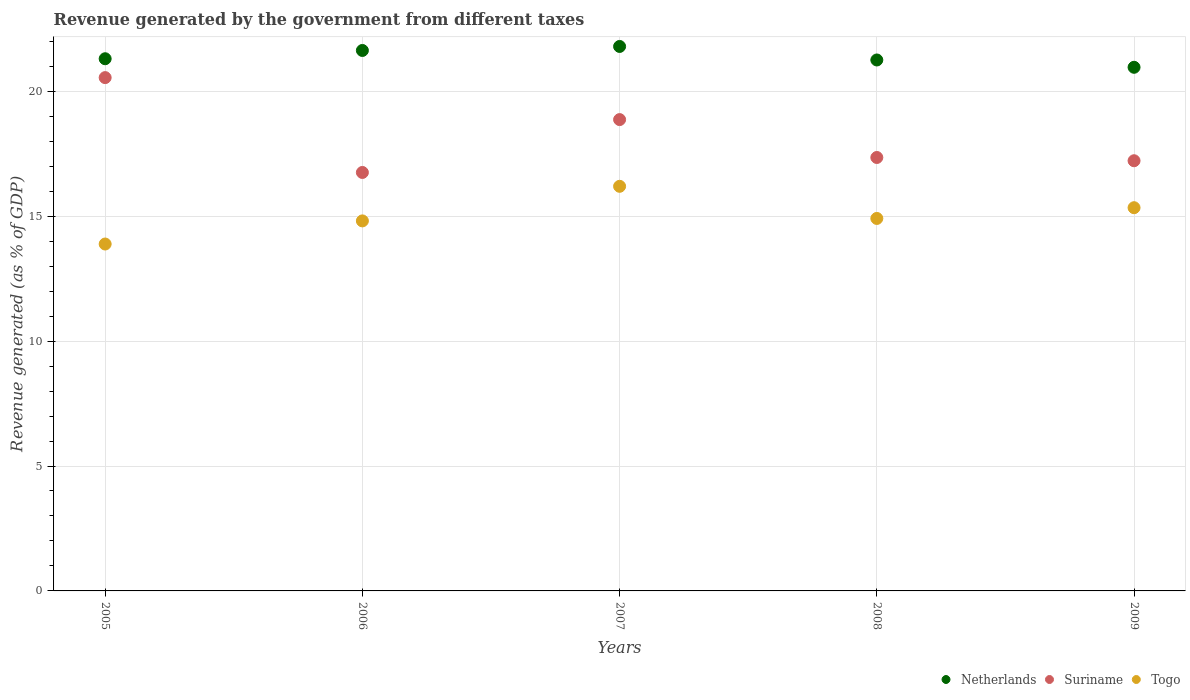How many different coloured dotlines are there?
Your response must be concise. 3. What is the revenue generated by the government in Netherlands in 2006?
Offer a terse response. 21.63. Across all years, what is the maximum revenue generated by the government in Togo?
Provide a short and direct response. 16.2. Across all years, what is the minimum revenue generated by the government in Suriname?
Offer a terse response. 16.75. In which year was the revenue generated by the government in Suriname maximum?
Provide a short and direct response. 2005. What is the total revenue generated by the government in Togo in the graph?
Your answer should be very brief. 75.14. What is the difference between the revenue generated by the government in Netherlands in 2007 and that in 2008?
Your response must be concise. 0.54. What is the difference between the revenue generated by the government in Togo in 2005 and the revenue generated by the government in Suriname in 2009?
Keep it short and to the point. -3.33. What is the average revenue generated by the government in Togo per year?
Offer a very short reply. 15.03. In the year 2006, what is the difference between the revenue generated by the government in Suriname and revenue generated by the government in Togo?
Provide a succinct answer. 1.94. In how many years, is the revenue generated by the government in Netherlands greater than 11 %?
Provide a short and direct response. 5. What is the ratio of the revenue generated by the government in Netherlands in 2005 to that in 2006?
Provide a short and direct response. 0.98. What is the difference between the highest and the second highest revenue generated by the government in Togo?
Your answer should be compact. 0.86. What is the difference between the highest and the lowest revenue generated by the government in Netherlands?
Ensure brevity in your answer.  0.83. Is it the case that in every year, the sum of the revenue generated by the government in Netherlands and revenue generated by the government in Suriname  is greater than the revenue generated by the government in Togo?
Make the answer very short. Yes. Does the revenue generated by the government in Netherlands monotonically increase over the years?
Your response must be concise. No. Is the revenue generated by the government in Netherlands strictly less than the revenue generated by the government in Togo over the years?
Provide a succinct answer. No. How many years are there in the graph?
Give a very brief answer. 5. Are the values on the major ticks of Y-axis written in scientific E-notation?
Your response must be concise. No. Does the graph contain any zero values?
Your answer should be compact. No. Where does the legend appear in the graph?
Make the answer very short. Bottom right. What is the title of the graph?
Provide a short and direct response. Revenue generated by the government from different taxes. Does "Haiti" appear as one of the legend labels in the graph?
Keep it short and to the point. No. What is the label or title of the Y-axis?
Keep it short and to the point. Revenue generated (as % of GDP). What is the Revenue generated (as % of GDP) in Netherlands in 2005?
Your response must be concise. 21.3. What is the Revenue generated (as % of GDP) of Suriname in 2005?
Provide a succinct answer. 20.55. What is the Revenue generated (as % of GDP) of Togo in 2005?
Your answer should be compact. 13.88. What is the Revenue generated (as % of GDP) of Netherlands in 2006?
Your response must be concise. 21.63. What is the Revenue generated (as % of GDP) of Suriname in 2006?
Your answer should be very brief. 16.75. What is the Revenue generated (as % of GDP) in Togo in 2006?
Offer a terse response. 14.81. What is the Revenue generated (as % of GDP) in Netherlands in 2007?
Offer a terse response. 21.79. What is the Revenue generated (as % of GDP) of Suriname in 2007?
Provide a short and direct response. 18.87. What is the Revenue generated (as % of GDP) of Togo in 2007?
Provide a succinct answer. 16.2. What is the Revenue generated (as % of GDP) in Netherlands in 2008?
Give a very brief answer. 21.25. What is the Revenue generated (as % of GDP) in Suriname in 2008?
Offer a terse response. 17.35. What is the Revenue generated (as % of GDP) of Togo in 2008?
Give a very brief answer. 14.91. What is the Revenue generated (as % of GDP) in Netherlands in 2009?
Provide a succinct answer. 20.96. What is the Revenue generated (as % of GDP) in Suriname in 2009?
Offer a terse response. 17.22. What is the Revenue generated (as % of GDP) in Togo in 2009?
Offer a terse response. 15.34. Across all years, what is the maximum Revenue generated (as % of GDP) of Netherlands?
Give a very brief answer. 21.79. Across all years, what is the maximum Revenue generated (as % of GDP) of Suriname?
Provide a short and direct response. 20.55. Across all years, what is the maximum Revenue generated (as % of GDP) of Togo?
Your answer should be very brief. 16.2. Across all years, what is the minimum Revenue generated (as % of GDP) of Netherlands?
Offer a terse response. 20.96. Across all years, what is the minimum Revenue generated (as % of GDP) of Suriname?
Offer a terse response. 16.75. Across all years, what is the minimum Revenue generated (as % of GDP) in Togo?
Give a very brief answer. 13.88. What is the total Revenue generated (as % of GDP) in Netherlands in the graph?
Offer a very short reply. 106.94. What is the total Revenue generated (as % of GDP) of Suriname in the graph?
Ensure brevity in your answer.  90.73. What is the total Revenue generated (as % of GDP) in Togo in the graph?
Your answer should be compact. 75.14. What is the difference between the Revenue generated (as % of GDP) in Netherlands in 2005 and that in 2006?
Make the answer very short. -0.33. What is the difference between the Revenue generated (as % of GDP) in Suriname in 2005 and that in 2006?
Give a very brief answer. 3.8. What is the difference between the Revenue generated (as % of GDP) of Togo in 2005 and that in 2006?
Your response must be concise. -0.93. What is the difference between the Revenue generated (as % of GDP) of Netherlands in 2005 and that in 2007?
Give a very brief answer. -0.49. What is the difference between the Revenue generated (as % of GDP) of Suriname in 2005 and that in 2007?
Keep it short and to the point. 1.68. What is the difference between the Revenue generated (as % of GDP) in Togo in 2005 and that in 2007?
Your response must be concise. -2.31. What is the difference between the Revenue generated (as % of GDP) of Netherlands in 2005 and that in 2008?
Make the answer very short. 0.05. What is the difference between the Revenue generated (as % of GDP) in Suriname in 2005 and that in 2008?
Keep it short and to the point. 3.2. What is the difference between the Revenue generated (as % of GDP) in Togo in 2005 and that in 2008?
Your response must be concise. -1.02. What is the difference between the Revenue generated (as % of GDP) of Netherlands in 2005 and that in 2009?
Ensure brevity in your answer.  0.34. What is the difference between the Revenue generated (as % of GDP) in Suriname in 2005 and that in 2009?
Offer a very short reply. 3.33. What is the difference between the Revenue generated (as % of GDP) in Togo in 2005 and that in 2009?
Offer a terse response. -1.45. What is the difference between the Revenue generated (as % of GDP) of Netherlands in 2006 and that in 2007?
Ensure brevity in your answer.  -0.16. What is the difference between the Revenue generated (as % of GDP) of Suriname in 2006 and that in 2007?
Your response must be concise. -2.12. What is the difference between the Revenue generated (as % of GDP) in Togo in 2006 and that in 2007?
Ensure brevity in your answer.  -1.38. What is the difference between the Revenue generated (as % of GDP) in Netherlands in 2006 and that in 2008?
Provide a succinct answer. 0.38. What is the difference between the Revenue generated (as % of GDP) of Suriname in 2006 and that in 2008?
Offer a very short reply. -0.6. What is the difference between the Revenue generated (as % of GDP) of Togo in 2006 and that in 2008?
Your response must be concise. -0.1. What is the difference between the Revenue generated (as % of GDP) of Netherlands in 2006 and that in 2009?
Your answer should be compact. 0.67. What is the difference between the Revenue generated (as % of GDP) of Suriname in 2006 and that in 2009?
Provide a succinct answer. -0.47. What is the difference between the Revenue generated (as % of GDP) in Togo in 2006 and that in 2009?
Provide a short and direct response. -0.53. What is the difference between the Revenue generated (as % of GDP) of Netherlands in 2007 and that in 2008?
Your answer should be very brief. 0.54. What is the difference between the Revenue generated (as % of GDP) in Suriname in 2007 and that in 2008?
Provide a succinct answer. 1.52. What is the difference between the Revenue generated (as % of GDP) of Togo in 2007 and that in 2008?
Your answer should be very brief. 1.29. What is the difference between the Revenue generated (as % of GDP) of Netherlands in 2007 and that in 2009?
Provide a short and direct response. 0.83. What is the difference between the Revenue generated (as % of GDP) in Suriname in 2007 and that in 2009?
Keep it short and to the point. 1.65. What is the difference between the Revenue generated (as % of GDP) in Togo in 2007 and that in 2009?
Offer a terse response. 0.86. What is the difference between the Revenue generated (as % of GDP) of Netherlands in 2008 and that in 2009?
Keep it short and to the point. 0.29. What is the difference between the Revenue generated (as % of GDP) of Suriname in 2008 and that in 2009?
Ensure brevity in your answer.  0.13. What is the difference between the Revenue generated (as % of GDP) in Togo in 2008 and that in 2009?
Your answer should be compact. -0.43. What is the difference between the Revenue generated (as % of GDP) of Netherlands in 2005 and the Revenue generated (as % of GDP) of Suriname in 2006?
Your answer should be compact. 4.55. What is the difference between the Revenue generated (as % of GDP) of Netherlands in 2005 and the Revenue generated (as % of GDP) of Togo in 2006?
Ensure brevity in your answer.  6.49. What is the difference between the Revenue generated (as % of GDP) in Suriname in 2005 and the Revenue generated (as % of GDP) in Togo in 2006?
Your answer should be very brief. 5.74. What is the difference between the Revenue generated (as % of GDP) in Netherlands in 2005 and the Revenue generated (as % of GDP) in Suriname in 2007?
Provide a short and direct response. 2.44. What is the difference between the Revenue generated (as % of GDP) in Netherlands in 2005 and the Revenue generated (as % of GDP) in Togo in 2007?
Ensure brevity in your answer.  5.11. What is the difference between the Revenue generated (as % of GDP) of Suriname in 2005 and the Revenue generated (as % of GDP) of Togo in 2007?
Give a very brief answer. 4.35. What is the difference between the Revenue generated (as % of GDP) of Netherlands in 2005 and the Revenue generated (as % of GDP) of Suriname in 2008?
Ensure brevity in your answer.  3.95. What is the difference between the Revenue generated (as % of GDP) in Netherlands in 2005 and the Revenue generated (as % of GDP) in Togo in 2008?
Offer a terse response. 6.39. What is the difference between the Revenue generated (as % of GDP) of Suriname in 2005 and the Revenue generated (as % of GDP) of Togo in 2008?
Keep it short and to the point. 5.64. What is the difference between the Revenue generated (as % of GDP) in Netherlands in 2005 and the Revenue generated (as % of GDP) in Suriname in 2009?
Your answer should be very brief. 4.08. What is the difference between the Revenue generated (as % of GDP) in Netherlands in 2005 and the Revenue generated (as % of GDP) in Togo in 2009?
Your answer should be very brief. 5.96. What is the difference between the Revenue generated (as % of GDP) of Suriname in 2005 and the Revenue generated (as % of GDP) of Togo in 2009?
Give a very brief answer. 5.21. What is the difference between the Revenue generated (as % of GDP) of Netherlands in 2006 and the Revenue generated (as % of GDP) of Suriname in 2007?
Ensure brevity in your answer.  2.77. What is the difference between the Revenue generated (as % of GDP) in Netherlands in 2006 and the Revenue generated (as % of GDP) in Togo in 2007?
Give a very brief answer. 5.44. What is the difference between the Revenue generated (as % of GDP) in Suriname in 2006 and the Revenue generated (as % of GDP) in Togo in 2007?
Your answer should be compact. 0.55. What is the difference between the Revenue generated (as % of GDP) of Netherlands in 2006 and the Revenue generated (as % of GDP) of Suriname in 2008?
Make the answer very short. 4.28. What is the difference between the Revenue generated (as % of GDP) of Netherlands in 2006 and the Revenue generated (as % of GDP) of Togo in 2008?
Your answer should be very brief. 6.72. What is the difference between the Revenue generated (as % of GDP) in Suriname in 2006 and the Revenue generated (as % of GDP) in Togo in 2008?
Ensure brevity in your answer.  1.84. What is the difference between the Revenue generated (as % of GDP) in Netherlands in 2006 and the Revenue generated (as % of GDP) in Suriname in 2009?
Your answer should be compact. 4.41. What is the difference between the Revenue generated (as % of GDP) in Netherlands in 2006 and the Revenue generated (as % of GDP) in Togo in 2009?
Make the answer very short. 6.29. What is the difference between the Revenue generated (as % of GDP) in Suriname in 2006 and the Revenue generated (as % of GDP) in Togo in 2009?
Your response must be concise. 1.41. What is the difference between the Revenue generated (as % of GDP) of Netherlands in 2007 and the Revenue generated (as % of GDP) of Suriname in 2008?
Make the answer very short. 4.44. What is the difference between the Revenue generated (as % of GDP) of Netherlands in 2007 and the Revenue generated (as % of GDP) of Togo in 2008?
Make the answer very short. 6.88. What is the difference between the Revenue generated (as % of GDP) in Suriname in 2007 and the Revenue generated (as % of GDP) in Togo in 2008?
Your response must be concise. 3.96. What is the difference between the Revenue generated (as % of GDP) in Netherlands in 2007 and the Revenue generated (as % of GDP) in Suriname in 2009?
Make the answer very short. 4.57. What is the difference between the Revenue generated (as % of GDP) of Netherlands in 2007 and the Revenue generated (as % of GDP) of Togo in 2009?
Make the answer very short. 6.45. What is the difference between the Revenue generated (as % of GDP) in Suriname in 2007 and the Revenue generated (as % of GDP) in Togo in 2009?
Offer a terse response. 3.53. What is the difference between the Revenue generated (as % of GDP) in Netherlands in 2008 and the Revenue generated (as % of GDP) in Suriname in 2009?
Make the answer very short. 4.03. What is the difference between the Revenue generated (as % of GDP) of Netherlands in 2008 and the Revenue generated (as % of GDP) of Togo in 2009?
Provide a succinct answer. 5.91. What is the difference between the Revenue generated (as % of GDP) in Suriname in 2008 and the Revenue generated (as % of GDP) in Togo in 2009?
Provide a short and direct response. 2.01. What is the average Revenue generated (as % of GDP) in Netherlands per year?
Keep it short and to the point. 21.39. What is the average Revenue generated (as % of GDP) of Suriname per year?
Your answer should be very brief. 18.15. What is the average Revenue generated (as % of GDP) of Togo per year?
Provide a succinct answer. 15.03. In the year 2005, what is the difference between the Revenue generated (as % of GDP) in Netherlands and Revenue generated (as % of GDP) in Suriname?
Provide a short and direct response. 0.76. In the year 2005, what is the difference between the Revenue generated (as % of GDP) in Netherlands and Revenue generated (as % of GDP) in Togo?
Ensure brevity in your answer.  7.42. In the year 2005, what is the difference between the Revenue generated (as % of GDP) in Suriname and Revenue generated (as % of GDP) in Togo?
Ensure brevity in your answer.  6.66. In the year 2006, what is the difference between the Revenue generated (as % of GDP) in Netherlands and Revenue generated (as % of GDP) in Suriname?
Your answer should be compact. 4.88. In the year 2006, what is the difference between the Revenue generated (as % of GDP) in Netherlands and Revenue generated (as % of GDP) in Togo?
Keep it short and to the point. 6.82. In the year 2006, what is the difference between the Revenue generated (as % of GDP) of Suriname and Revenue generated (as % of GDP) of Togo?
Offer a terse response. 1.94. In the year 2007, what is the difference between the Revenue generated (as % of GDP) of Netherlands and Revenue generated (as % of GDP) of Suriname?
Your answer should be compact. 2.93. In the year 2007, what is the difference between the Revenue generated (as % of GDP) in Netherlands and Revenue generated (as % of GDP) in Togo?
Give a very brief answer. 5.6. In the year 2007, what is the difference between the Revenue generated (as % of GDP) of Suriname and Revenue generated (as % of GDP) of Togo?
Provide a short and direct response. 2.67. In the year 2008, what is the difference between the Revenue generated (as % of GDP) in Netherlands and Revenue generated (as % of GDP) in Suriname?
Provide a succinct answer. 3.9. In the year 2008, what is the difference between the Revenue generated (as % of GDP) of Netherlands and Revenue generated (as % of GDP) of Togo?
Your response must be concise. 6.34. In the year 2008, what is the difference between the Revenue generated (as % of GDP) of Suriname and Revenue generated (as % of GDP) of Togo?
Provide a succinct answer. 2.44. In the year 2009, what is the difference between the Revenue generated (as % of GDP) in Netherlands and Revenue generated (as % of GDP) in Suriname?
Give a very brief answer. 3.74. In the year 2009, what is the difference between the Revenue generated (as % of GDP) of Netherlands and Revenue generated (as % of GDP) of Togo?
Provide a short and direct response. 5.62. In the year 2009, what is the difference between the Revenue generated (as % of GDP) in Suriname and Revenue generated (as % of GDP) in Togo?
Give a very brief answer. 1.88. What is the ratio of the Revenue generated (as % of GDP) in Netherlands in 2005 to that in 2006?
Offer a very short reply. 0.98. What is the ratio of the Revenue generated (as % of GDP) in Suriname in 2005 to that in 2006?
Your response must be concise. 1.23. What is the ratio of the Revenue generated (as % of GDP) of Togo in 2005 to that in 2006?
Your answer should be very brief. 0.94. What is the ratio of the Revenue generated (as % of GDP) of Netherlands in 2005 to that in 2007?
Your answer should be very brief. 0.98. What is the ratio of the Revenue generated (as % of GDP) of Suriname in 2005 to that in 2007?
Offer a very short reply. 1.09. What is the ratio of the Revenue generated (as % of GDP) of Togo in 2005 to that in 2007?
Give a very brief answer. 0.86. What is the ratio of the Revenue generated (as % of GDP) in Netherlands in 2005 to that in 2008?
Provide a short and direct response. 1. What is the ratio of the Revenue generated (as % of GDP) of Suriname in 2005 to that in 2008?
Make the answer very short. 1.18. What is the ratio of the Revenue generated (as % of GDP) of Togo in 2005 to that in 2008?
Provide a short and direct response. 0.93. What is the ratio of the Revenue generated (as % of GDP) of Netherlands in 2005 to that in 2009?
Ensure brevity in your answer.  1.02. What is the ratio of the Revenue generated (as % of GDP) of Suriname in 2005 to that in 2009?
Make the answer very short. 1.19. What is the ratio of the Revenue generated (as % of GDP) of Togo in 2005 to that in 2009?
Provide a succinct answer. 0.91. What is the ratio of the Revenue generated (as % of GDP) in Netherlands in 2006 to that in 2007?
Keep it short and to the point. 0.99. What is the ratio of the Revenue generated (as % of GDP) in Suriname in 2006 to that in 2007?
Give a very brief answer. 0.89. What is the ratio of the Revenue generated (as % of GDP) of Togo in 2006 to that in 2007?
Your answer should be very brief. 0.91. What is the ratio of the Revenue generated (as % of GDP) of Netherlands in 2006 to that in 2008?
Offer a terse response. 1.02. What is the ratio of the Revenue generated (as % of GDP) in Suriname in 2006 to that in 2008?
Provide a short and direct response. 0.97. What is the ratio of the Revenue generated (as % of GDP) in Togo in 2006 to that in 2008?
Offer a very short reply. 0.99. What is the ratio of the Revenue generated (as % of GDP) in Netherlands in 2006 to that in 2009?
Ensure brevity in your answer.  1.03. What is the ratio of the Revenue generated (as % of GDP) in Suriname in 2006 to that in 2009?
Offer a terse response. 0.97. What is the ratio of the Revenue generated (as % of GDP) in Togo in 2006 to that in 2009?
Your answer should be compact. 0.97. What is the ratio of the Revenue generated (as % of GDP) in Netherlands in 2007 to that in 2008?
Offer a terse response. 1.03. What is the ratio of the Revenue generated (as % of GDP) of Suriname in 2007 to that in 2008?
Your response must be concise. 1.09. What is the ratio of the Revenue generated (as % of GDP) of Togo in 2007 to that in 2008?
Ensure brevity in your answer.  1.09. What is the ratio of the Revenue generated (as % of GDP) in Netherlands in 2007 to that in 2009?
Make the answer very short. 1.04. What is the ratio of the Revenue generated (as % of GDP) in Suriname in 2007 to that in 2009?
Provide a short and direct response. 1.1. What is the ratio of the Revenue generated (as % of GDP) of Togo in 2007 to that in 2009?
Provide a succinct answer. 1.06. What is the ratio of the Revenue generated (as % of GDP) of Suriname in 2008 to that in 2009?
Keep it short and to the point. 1.01. What is the ratio of the Revenue generated (as % of GDP) in Togo in 2008 to that in 2009?
Provide a succinct answer. 0.97. What is the difference between the highest and the second highest Revenue generated (as % of GDP) in Netherlands?
Your response must be concise. 0.16. What is the difference between the highest and the second highest Revenue generated (as % of GDP) of Suriname?
Your response must be concise. 1.68. What is the difference between the highest and the second highest Revenue generated (as % of GDP) of Togo?
Your response must be concise. 0.86. What is the difference between the highest and the lowest Revenue generated (as % of GDP) of Netherlands?
Your response must be concise. 0.83. What is the difference between the highest and the lowest Revenue generated (as % of GDP) in Suriname?
Your answer should be very brief. 3.8. What is the difference between the highest and the lowest Revenue generated (as % of GDP) in Togo?
Ensure brevity in your answer.  2.31. 